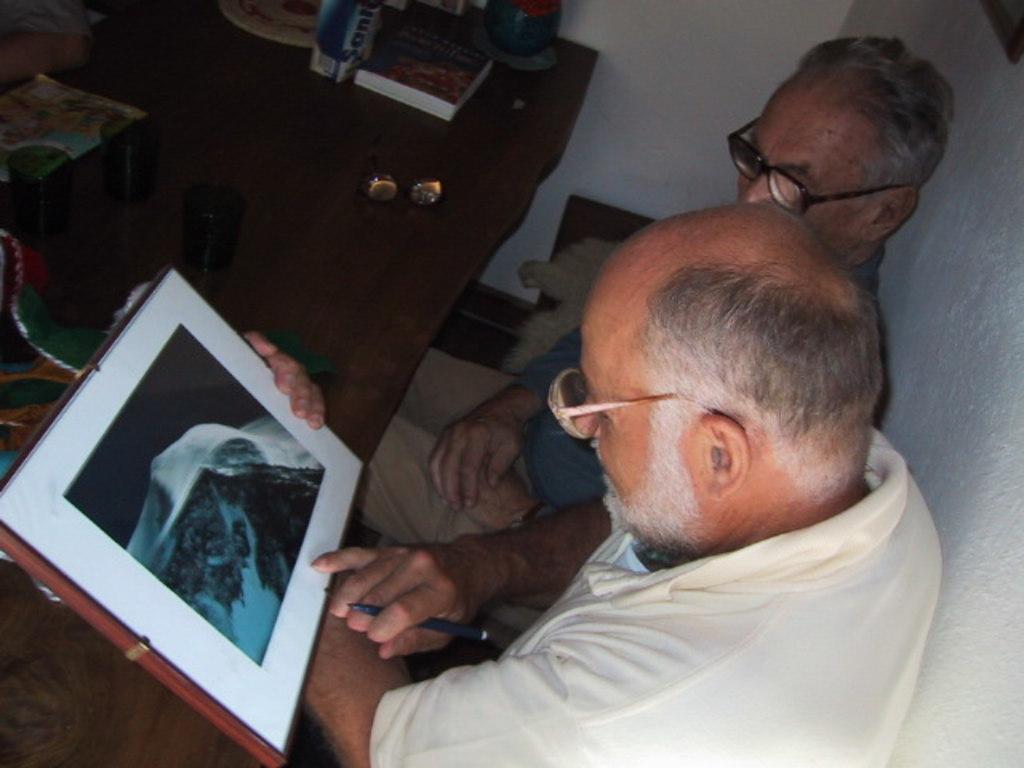How would you summarize this image in a sentence or two? In this picture we can see two men are sitting in front of a table, a man in the front is holding a pen and a photo frame, we can see two glasses, books and other things present on the table, in the background there is a wall. 